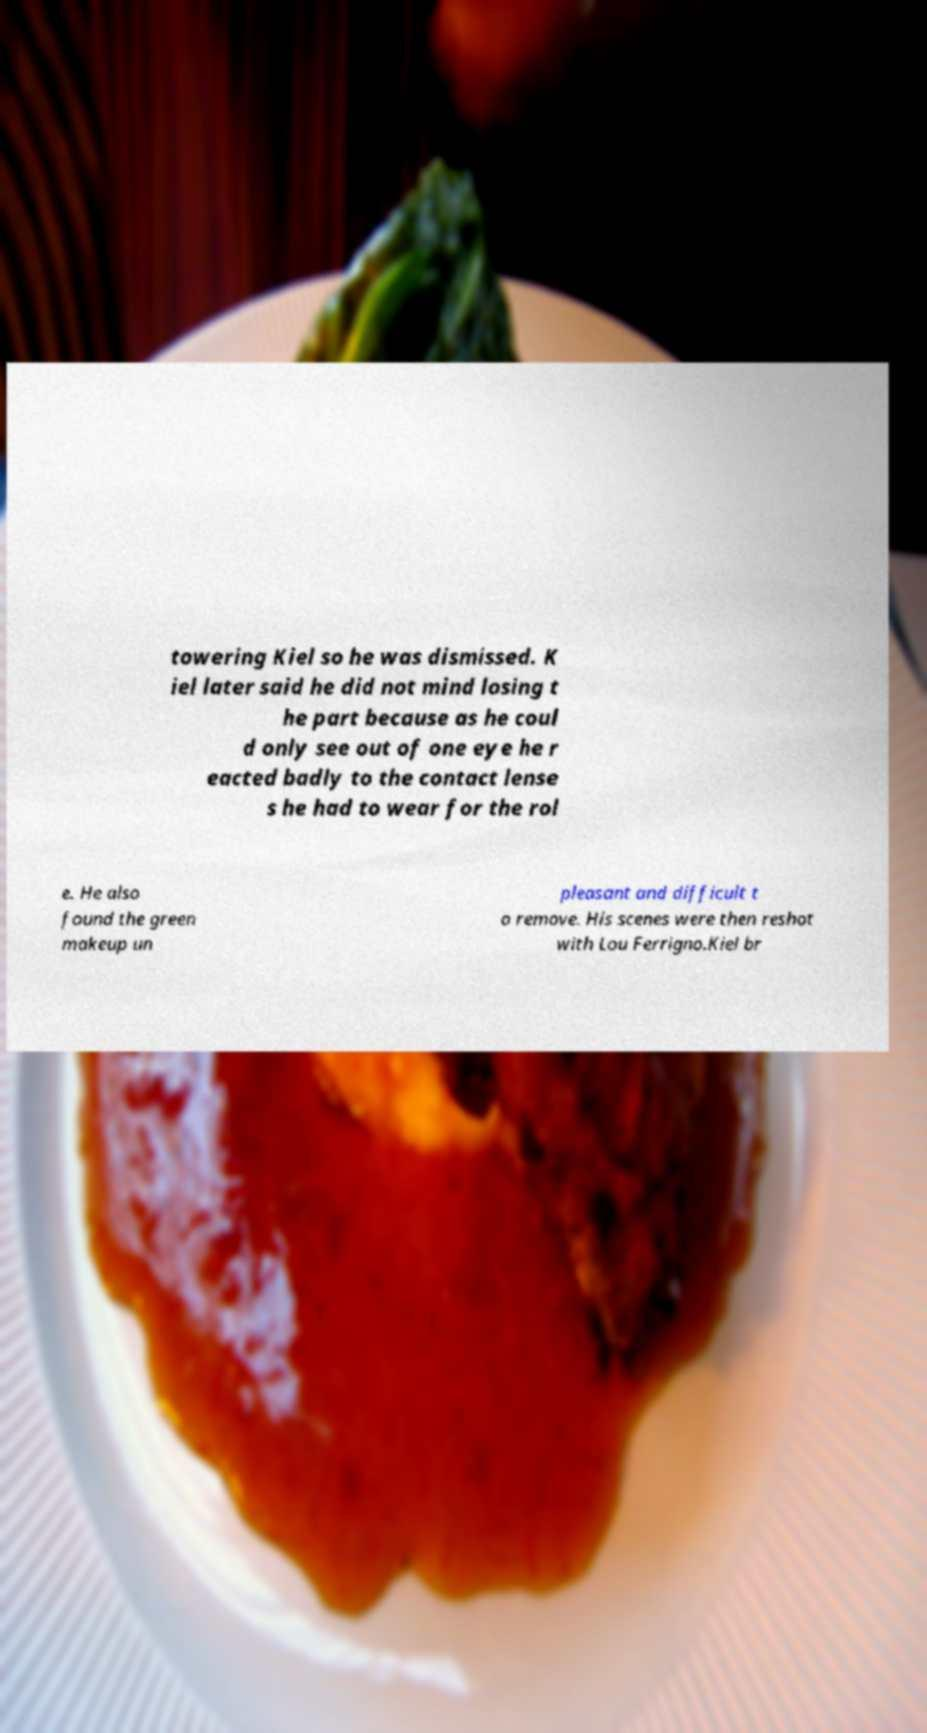For documentation purposes, I need the text within this image transcribed. Could you provide that? towering Kiel so he was dismissed. K iel later said he did not mind losing t he part because as he coul d only see out of one eye he r eacted badly to the contact lense s he had to wear for the rol e. He also found the green makeup un pleasant and difficult t o remove. His scenes were then reshot with Lou Ferrigno.Kiel br 